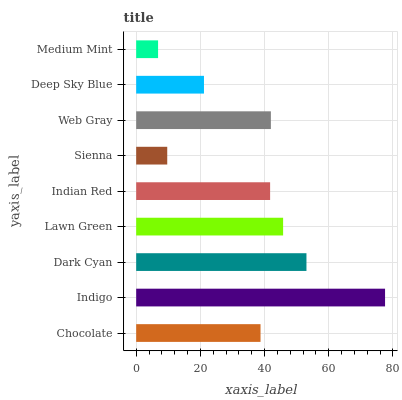Is Medium Mint the minimum?
Answer yes or no. Yes. Is Indigo the maximum?
Answer yes or no. Yes. Is Dark Cyan the minimum?
Answer yes or no. No. Is Dark Cyan the maximum?
Answer yes or no. No. Is Indigo greater than Dark Cyan?
Answer yes or no. Yes. Is Dark Cyan less than Indigo?
Answer yes or no. Yes. Is Dark Cyan greater than Indigo?
Answer yes or no. No. Is Indigo less than Dark Cyan?
Answer yes or no. No. Is Indian Red the high median?
Answer yes or no. Yes. Is Indian Red the low median?
Answer yes or no. Yes. Is Deep Sky Blue the high median?
Answer yes or no. No. Is Dark Cyan the low median?
Answer yes or no. No. 